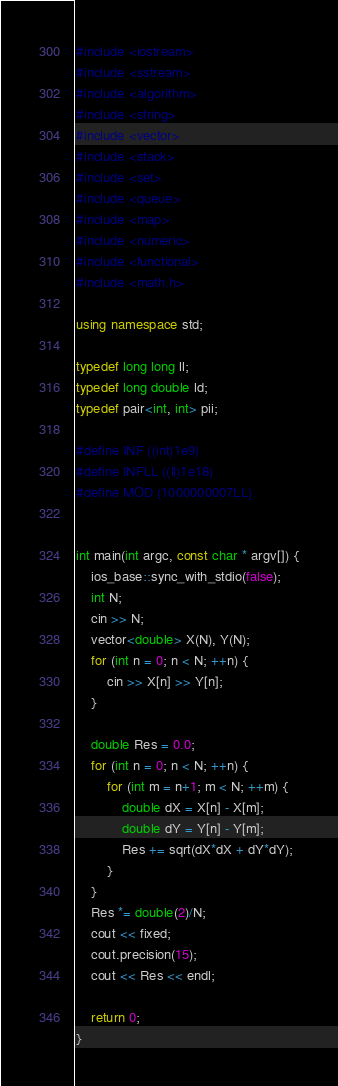Convert code to text. <code><loc_0><loc_0><loc_500><loc_500><_C++_>#include <iostream>
#include <sstream>
#include <algorithm>
#include <string>
#include <vector>
#include <stack>
#include <set>
#include <queue>
#include <map>
#include <numeric>
#include <functional>
#include <math.h>

using namespace std;

typedef long long ll;
typedef long double ld;
typedef pair<int, int> pii;

#define INF ((int)1e9)
#define INFLL ((ll)1e18)
#define MOD (1000000007LL)


int main(int argc, const char * argv[]) {
    ios_base::sync_with_stdio(false);
    int N;
    cin >> N;
    vector<double> X(N), Y(N);
    for (int n = 0; n < N; ++n) {
        cin >> X[n] >> Y[n];
    }
    
    double Res = 0.0;
    for (int n = 0; n < N; ++n) {
        for (int m = n+1; m < N; ++m) {
            double dX = X[n] - X[m];
            double dY = Y[n] - Y[m];
            Res += sqrt(dX*dX + dY*dY);
        }
    }
    Res *= double(2)/N;
    cout << fixed;
    cout.precision(15);
    cout << Res << endl;

    return 0;
}
</code> 